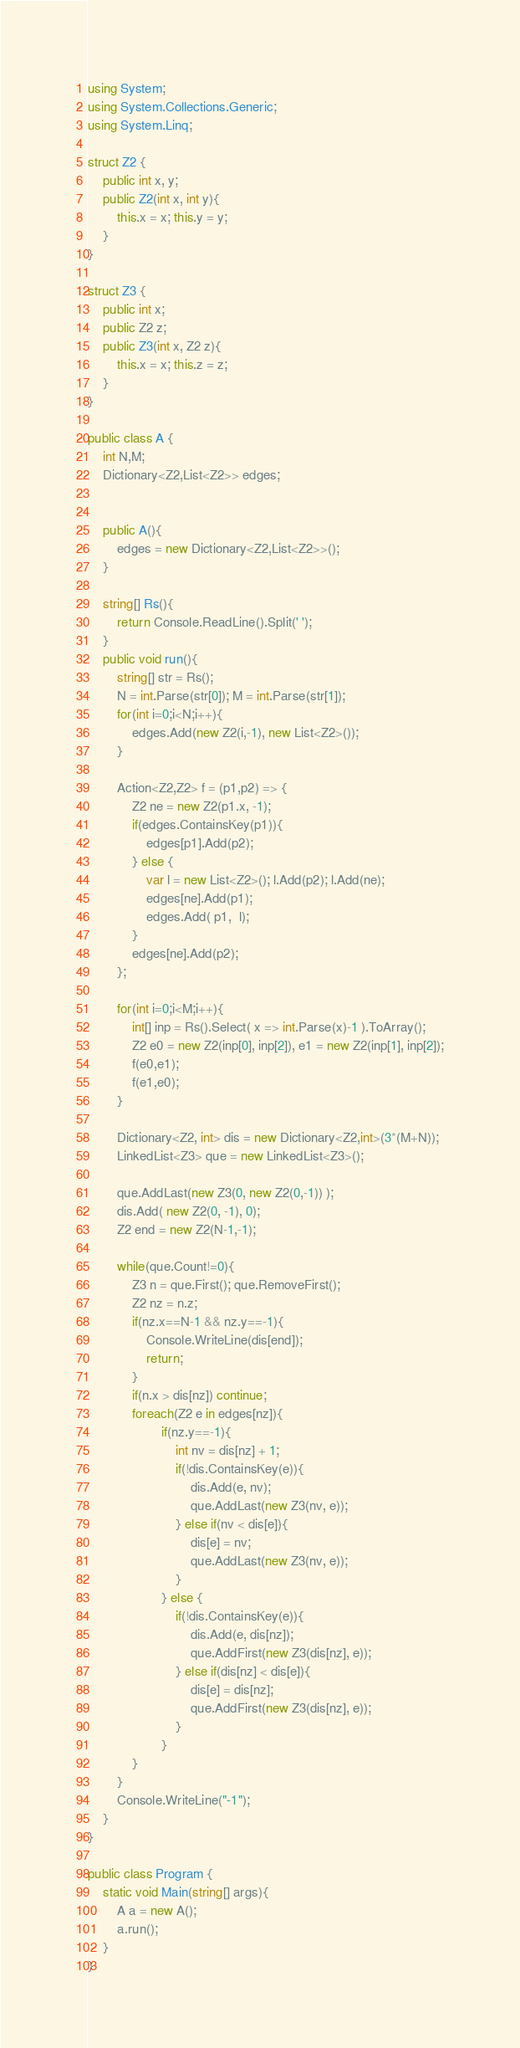<code> <loc_0><loc_0><loc_500><loc_500><_C#_>using System;
using System.Collections.Generic;
using System.Linq;
 
struct Z2 {
	public int x, y;
	public Z2(int x, int y){
		this.x = x; this.y = y;
	}
}
 
struct Z3 {
	public int x;
	public Z2 z;
	public Z3(int x, Z2 z){
		this.x = x; this.z = z;
	}
}
 
public class A {
	int N,M;
	Dictionary<Z2,List<Z2>> edges;
    
	
	public A(){
		edges = new Dictionary<Z2,List<Z2>>();
	}
	
	string[] Rs(){
		return Console.ReadLine().Split(' ');
	}
	public void run(){
		string[] str = Rs();
		N = int.Parse(str[0]); M = int.Parse(str[1]);
		for(int i=0;i<N;i++){
            edges.Add(new Z2(i,-1), new List<Z2>());
        }
        
        Action<Z2,Z2> f = (p1,p2) => {
            Z2 ne = new Z2(p1.x, -1);
			if(edges.ContainsKey(p1)){
                edges[p1].Add(p2);
            } else {
                var l = new List<Z2>(); l.Add(p2); l.Add(ne); 
				edges[ne].Add(p1);
                edges.Add( p1,  l);
            }
            edges[ne].Add(p2);
        };
        
        for(int i=0;i<M;i++){
			int[] inp = Rs().Select( x => int.Parse(x)-1 ).ToArray();
            Z2 e0 = new Z2(inp[0], inp[2]), e1 = new Z2(inp[1], inp[2]);
            f(e0,e1);
            f(e1,e0);
        }
        
        Dictionary<Z2, int> dis = new Dictionary<Z2,int>(3*(M+N));
		LinkedList<Z3> que = new LinkedList<Z3>();
		
		que.AddLast(new Z3(0, new Z2(0,-1)) ); 
		dis.Add( new Z2(0, -1), 0);
        Z2 end = new Z2(N-1,-1);
        
		while(que.Count!=0){
			Z3 n = que.First(); que.RemoveFirst();
			Z2 nz = n.z;
			if(nz.x==N-1 && nz.y==-1){ 
				Console.WriteLine(dis[end]);
				return;
			}
			if(n.x > dis[nz]) continue;
            foreach(Z2 e in edges[nz]){
					if(nz.y==-1){
						int nv = dis[nz] + 1;
	                    if(!dis.ContainsKey(e)){
							dis.Add(e, nv);
							que.AddLast(new Z3(nv, e));
	                    } else if(nv < dis[e]){
							dis[e] = nv;
							que.AddLast(new Z3(nv, e));
						}
					} else {
						if(!dis.ContainsKey(e)){
							dis.Add(e, dis[nz]);
							que.AddFirst(new Z3(dis[nz], e));
	                    } else if(dis[nz] < dis[e]){
							dis[e] = dis[nz];
							que.AddFirst(new Z3(dis[nz], e));
						}
					}
            }
        }
		Console.WriteLine("-1");
	}
}
 
public class Program {
	static void Main(string[] args){
		A a = new A();
		a.run();
	}
}</code> 